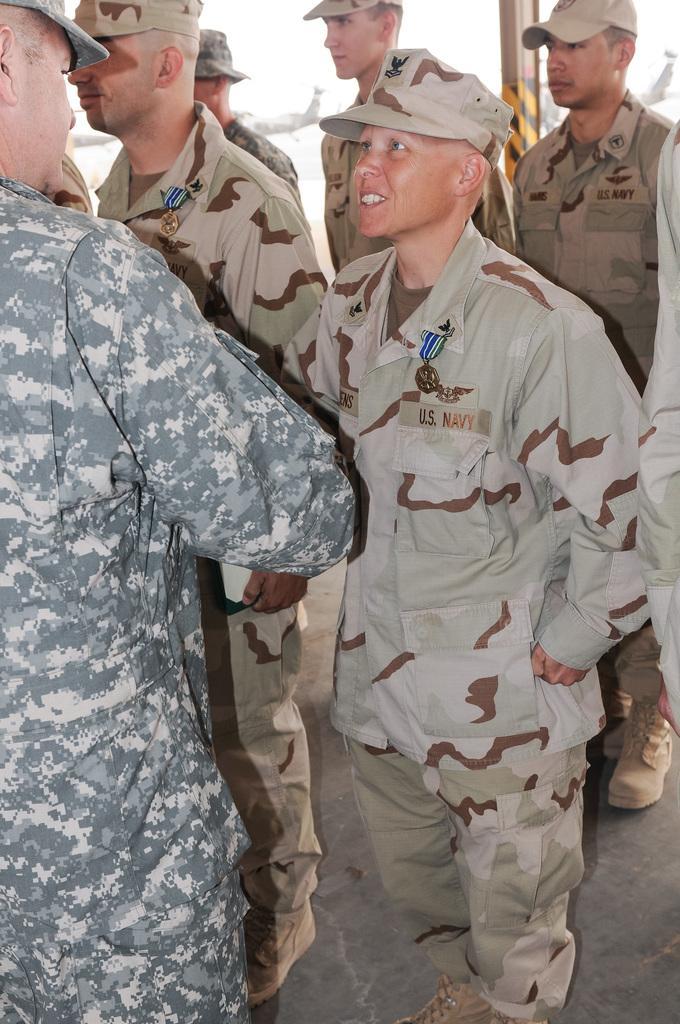Please provide a concise description of this image. In this image there are people standing on a floor. 